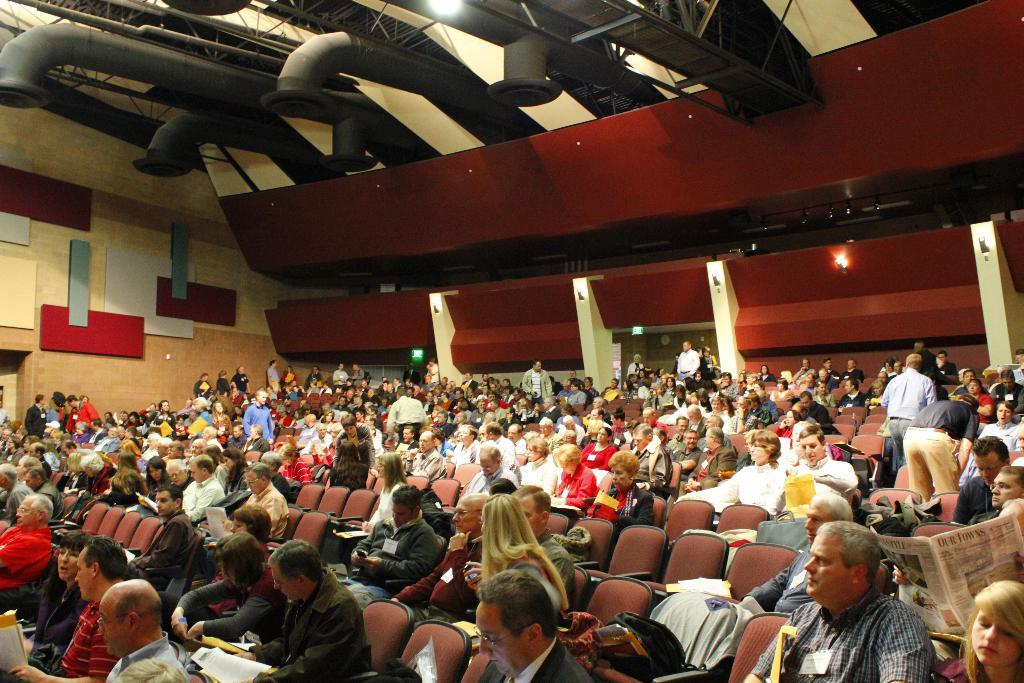What are the people in the image doing? The people in the image are sitting on chairs. What can be seen at the top of the image? There are ducts visible at the top of the image. What is the primary architectural feature in the image? There are walls in the image. What type of stem is growing out of the coat in the image? There is no stem or coat present in the image. 